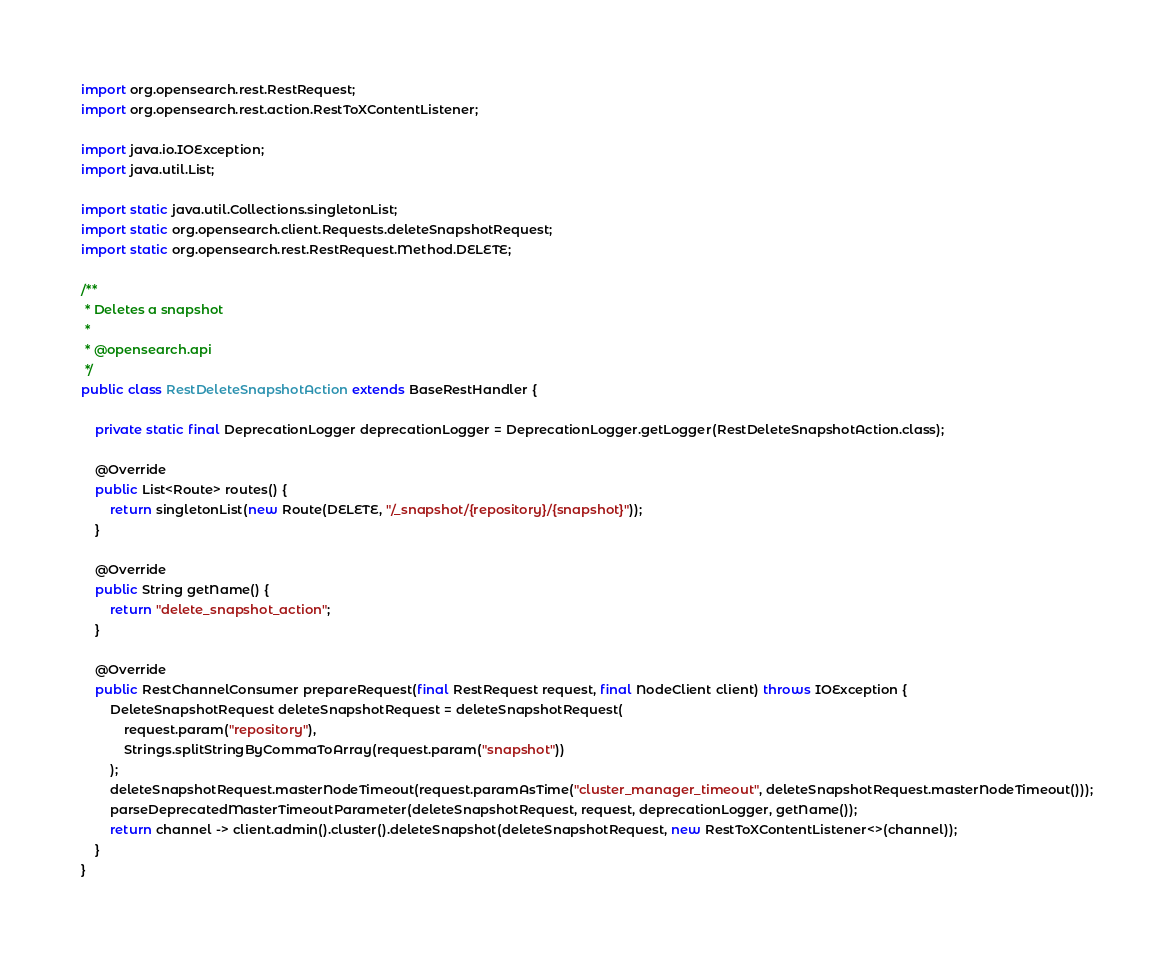<code> <loc_0><loc_0><loc_500><loc_500><_Java_>import org.opensearch.rest.RestRequest;
import org.opensearch.rest.action.RestToXContentListener;

import java.io.IOException;
import java.util.List;

import static java.util.Collections.singletonList;
import static org.opensearch.client.Requests.deleteSnapshotRequest;
import static org.opensearch.rest.RestRequest.Method.DELETE;

/**
 * Deletes a snapshot
 *
 * @opensearch.api
 */
public class RestDeleteSnapshotAction extends BaseRestHandler {

    private static final DeprecationLogger deprecationLogger = DeprecationLogger.getLogger(RestDeleteSnapshotAction.class);

    @Override
    public List<Route> routes() {
        return singletonList(new Route(DELETE, "/_snapshot/{repository}/{snapshot}"));
    }

    @Override
    public String getName() {
        return "delete_snapshot_action";
    }

    @Override
    public RestChannelConsumer prepareRequest(final RestRequest request, final NodeClient client) throws IOException {
        DeleteSnapshotRequest deleteSnapshotRequest = deleteSnapshotRequest(
            request.param("repository"),
            Strings.splitStringByCommaToArray(request.param("snapshot"))
        );
        deleteSnapshotRequest.masterNodeTimeout(request.paramAsTime("cluster_manager_timeout", deleteSnapshotRequest.masterNodeTimeout()));
        parseDeprecatedMasterTimeoutParameter(deleteSnapshotRequest, request, deprecationLogger, getName());
        return channel -> client.admin().cluster().deleteSnapshot(deleteSnapshotRequest, new RestToXContentListener<>(channel));
    }
}
</code> 